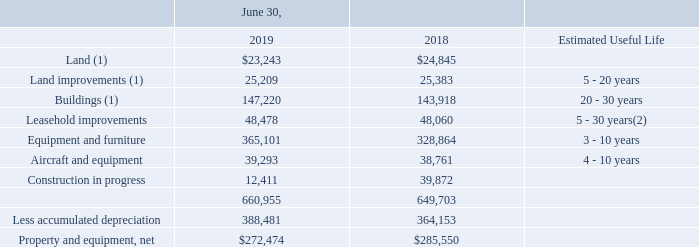NOTE 3. PROPERTY AND EQUIPMENT
The classification of property and equipment, together with their estimated useful lives is as follows:
(1) Excludes assets held for sale
(2) Lesser of lease term or estimated useful life
The change in property and equipment in accrued liabilities was $14,315 and $15,674 for the fiscal years ended June 30, 2019 and 2018, respectively. These amounts were excluded from capital expenditures on the statements of cash flows.
No impairments of property and equipment were recorded in fiscal 2019 or 2018.
During the third quarter of fiscal 2019, the Company received an unsolicited offer to purchase its Houston, TX, facility. At June 30, 2019, the facility included assets with a carrying value of approximately $5,055. Although management has not committed to the sale, a sale of the facility during fiscal 2020 is likely and the Company expects to record a gain on the sale upon closing, since the offer represents full appraisal value for the facility. Therefore, the assets are considered held for sale at June 30, 2019. Also held for sale at June 30, 2019, was the Company’s Elizabethtown, KY facility. During the third quarter of fiscal 2018, the Company reached a definitive agreement to sell the property for $1,300 pending an expected closing date during the second quarter of fiscal 2020. An impairment loss was recorded on this facility during fiscal 2017 as disclosed in Note 2 to the Company’s consolidated financial statements. Total assets held for sale by the Company at June 30, 2019 and 2018 were $6,355 and $1,300, respectively, and were included in assets held for sale on the Company’s consolidated balance sheet for each year. Those balances are not included on the above table.
What is the estimated useful life of land improvements? 5 - 20 years. What is the estimated useful life of buildings? 20 - 30 years. What is the estimated useful life of leasehold improvements? 5 - 30 years. What is the average land amount for 2018 and 2019? (23,243+24,845)/2
Answer: 24044. What is the average buildings amount for 2018 and 2019? (147,220+143,918)/2
Answer: 145569. Between 2018 and 2019 year end, which year had a higher amount of equipment and furniture? 365,101>328,864
Answer: 2019. 